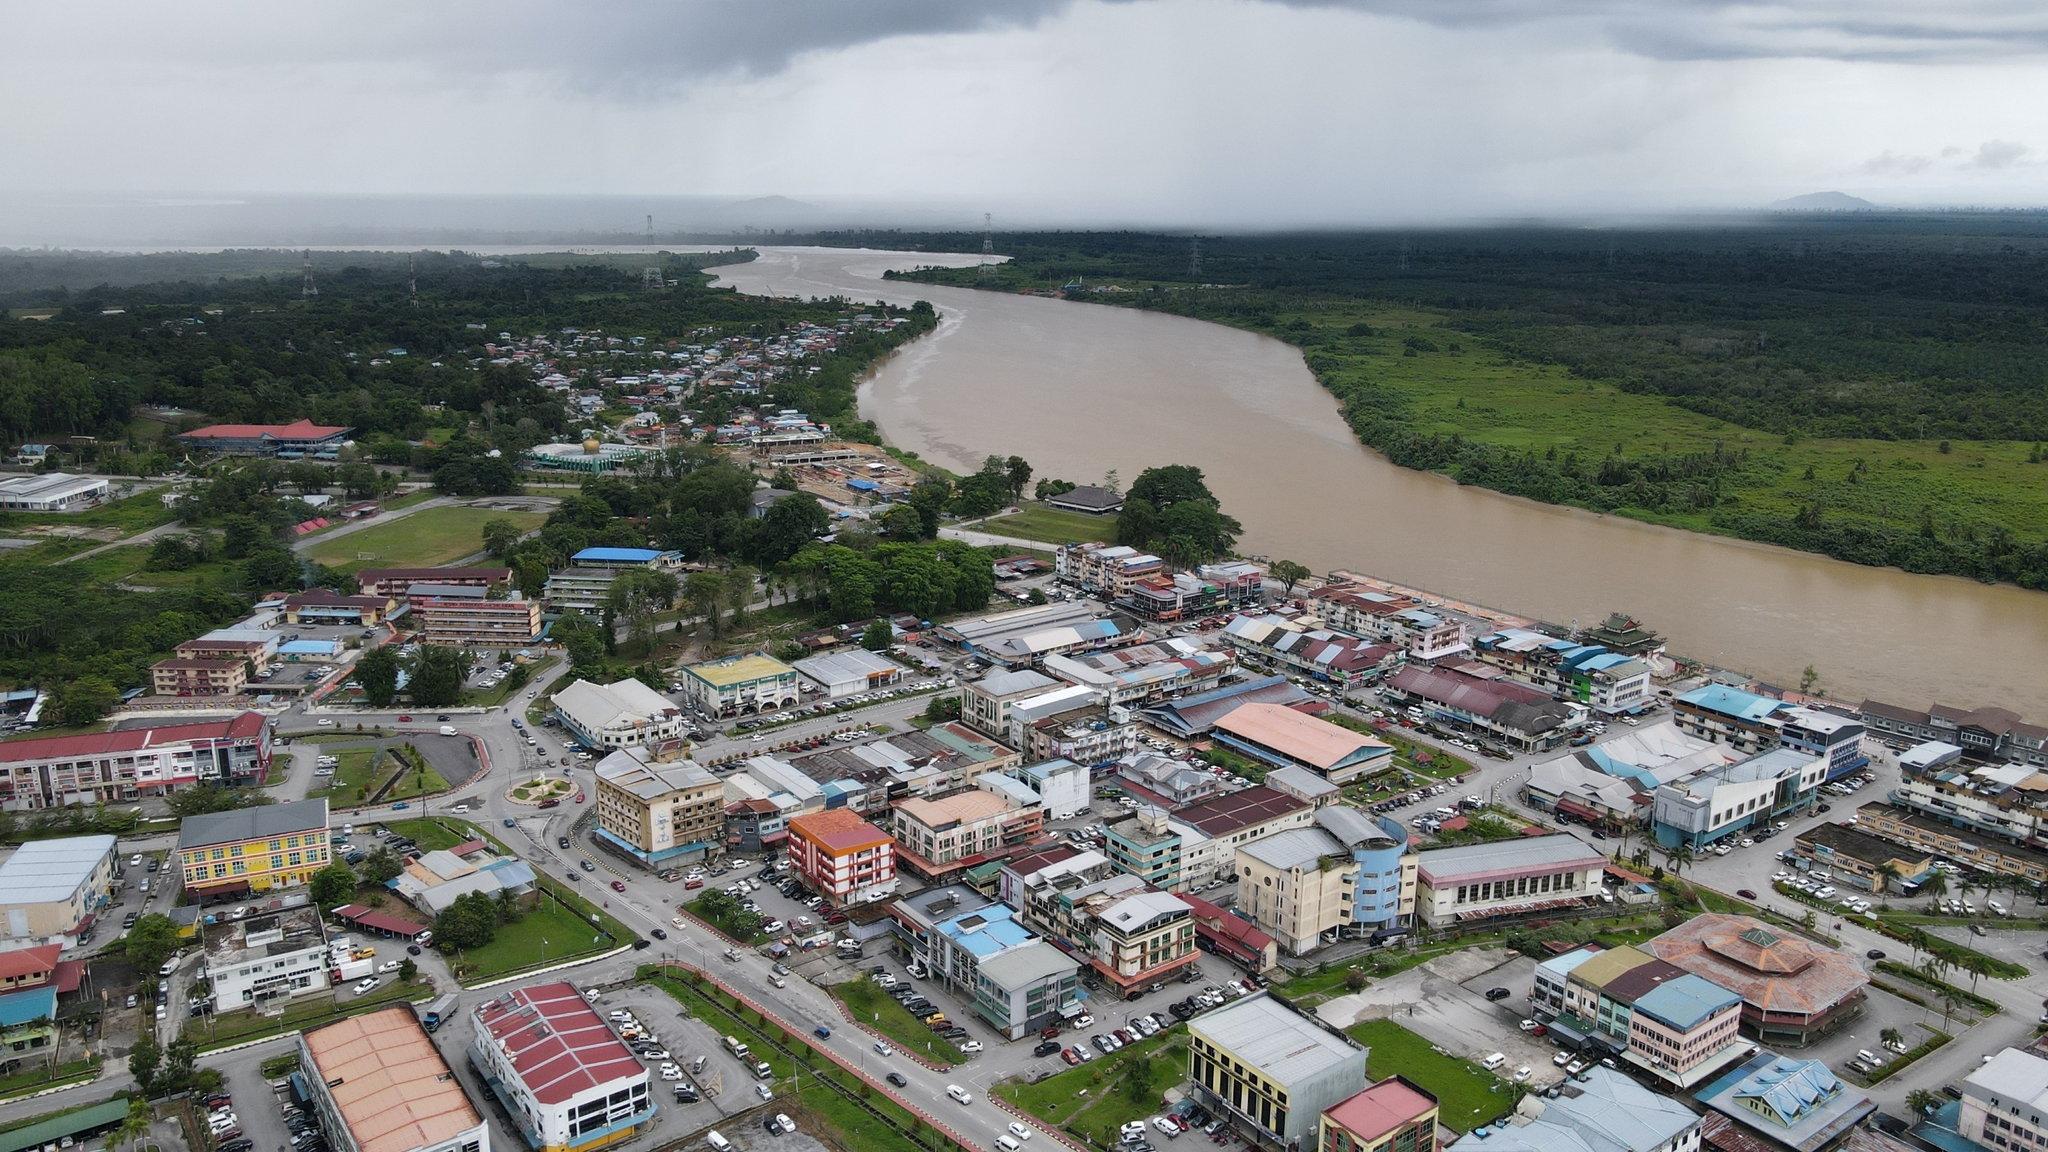Describe in detail the environmental challenges this town might face and possible solutions. Given the town's close proximity to a wide river, it likely faces significant environmental challenges such as flooding, pollution, and land erosion. During heavy rains or seasonal monsoons, the river can overflow, inundating homes, businesses, and critical infrastructure. To combat this, the town could invest in improved drainage systems, building robust flood barriers, and establishing early warning systems to prepare for and mitigate flood impacts. Pollution is another concern, as urban runoff and waste can contaminate the river, affecting both the local ecosystem and the health of residents. Public awareness campaigns to promote proper waste disposal, recycling programs, and stricter regulations on industrial discharges might help address this issue. Land erosion along the riverbanks due to natural or human activities can threaten properties and reduce agricultural productivity. Implementing soil conservation practices, planting vegetation along the banks to strengthen root structures, and designing sustainable land use plans can mitigate erosion. Cooperation with environmental organizations and leveraging technology for ongoing monitoring of environmental conditions would also play a crucial role in ensuring the town's resilience against these challenges. How does the community participate in these environmental efforts? The community plays a pivotal role in environmental preservation by actively participating in various initiatives and programs. Neighborhood associations might organize regular river clean-up events, where residents come together to collect litter and debris from the riverbanks. Educational programs in schools and community centers raise awareness among children and adults about the importance of environmental stewardship and sustainable practices. Local businesses can take part by adopting greener operations, such as reducing plastic use and managing waste responsibly. Volunteer groups could collaborate with municipal authorities to plant trees and shrubs along the riverbanks, which not only prevent erosion but also enhance the town's natural beauty. Residents might also be involved in community-led workshops where they learn and share ideas on water conservation, recycling, and energy-saving techniques. Such community-driven efforts build a stronger, more resilient relationship with the environment, fostering a sense of collective responsibility and pride in preserving the town's natural resources for future generations. 